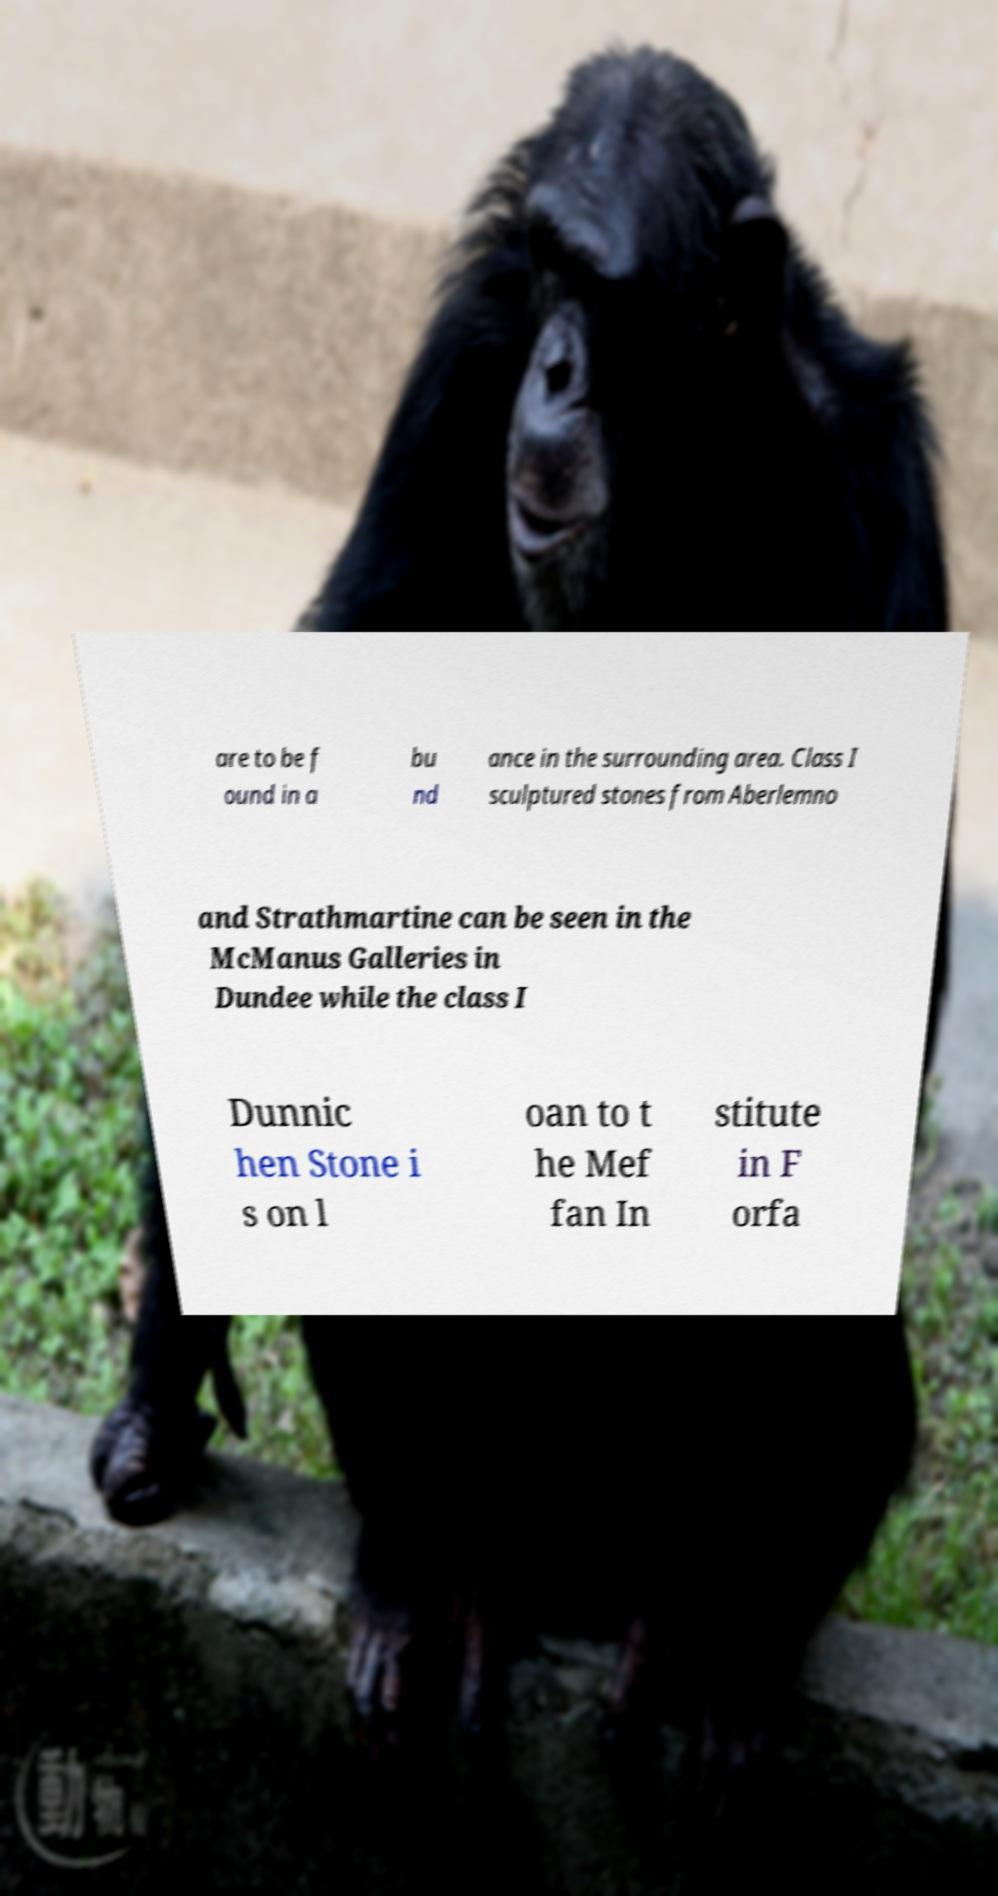Please identify and transcribe the text found in this image. are to be f ound in a bu nd ance in the surrounding area. Class I sculptured stones from Aberlemno and Strathmartine can be seen in the McManus Galleries in Dundee while the class I Dunnic hen Stone i s on l oan to t he Mef fan In stitute in F orfa 